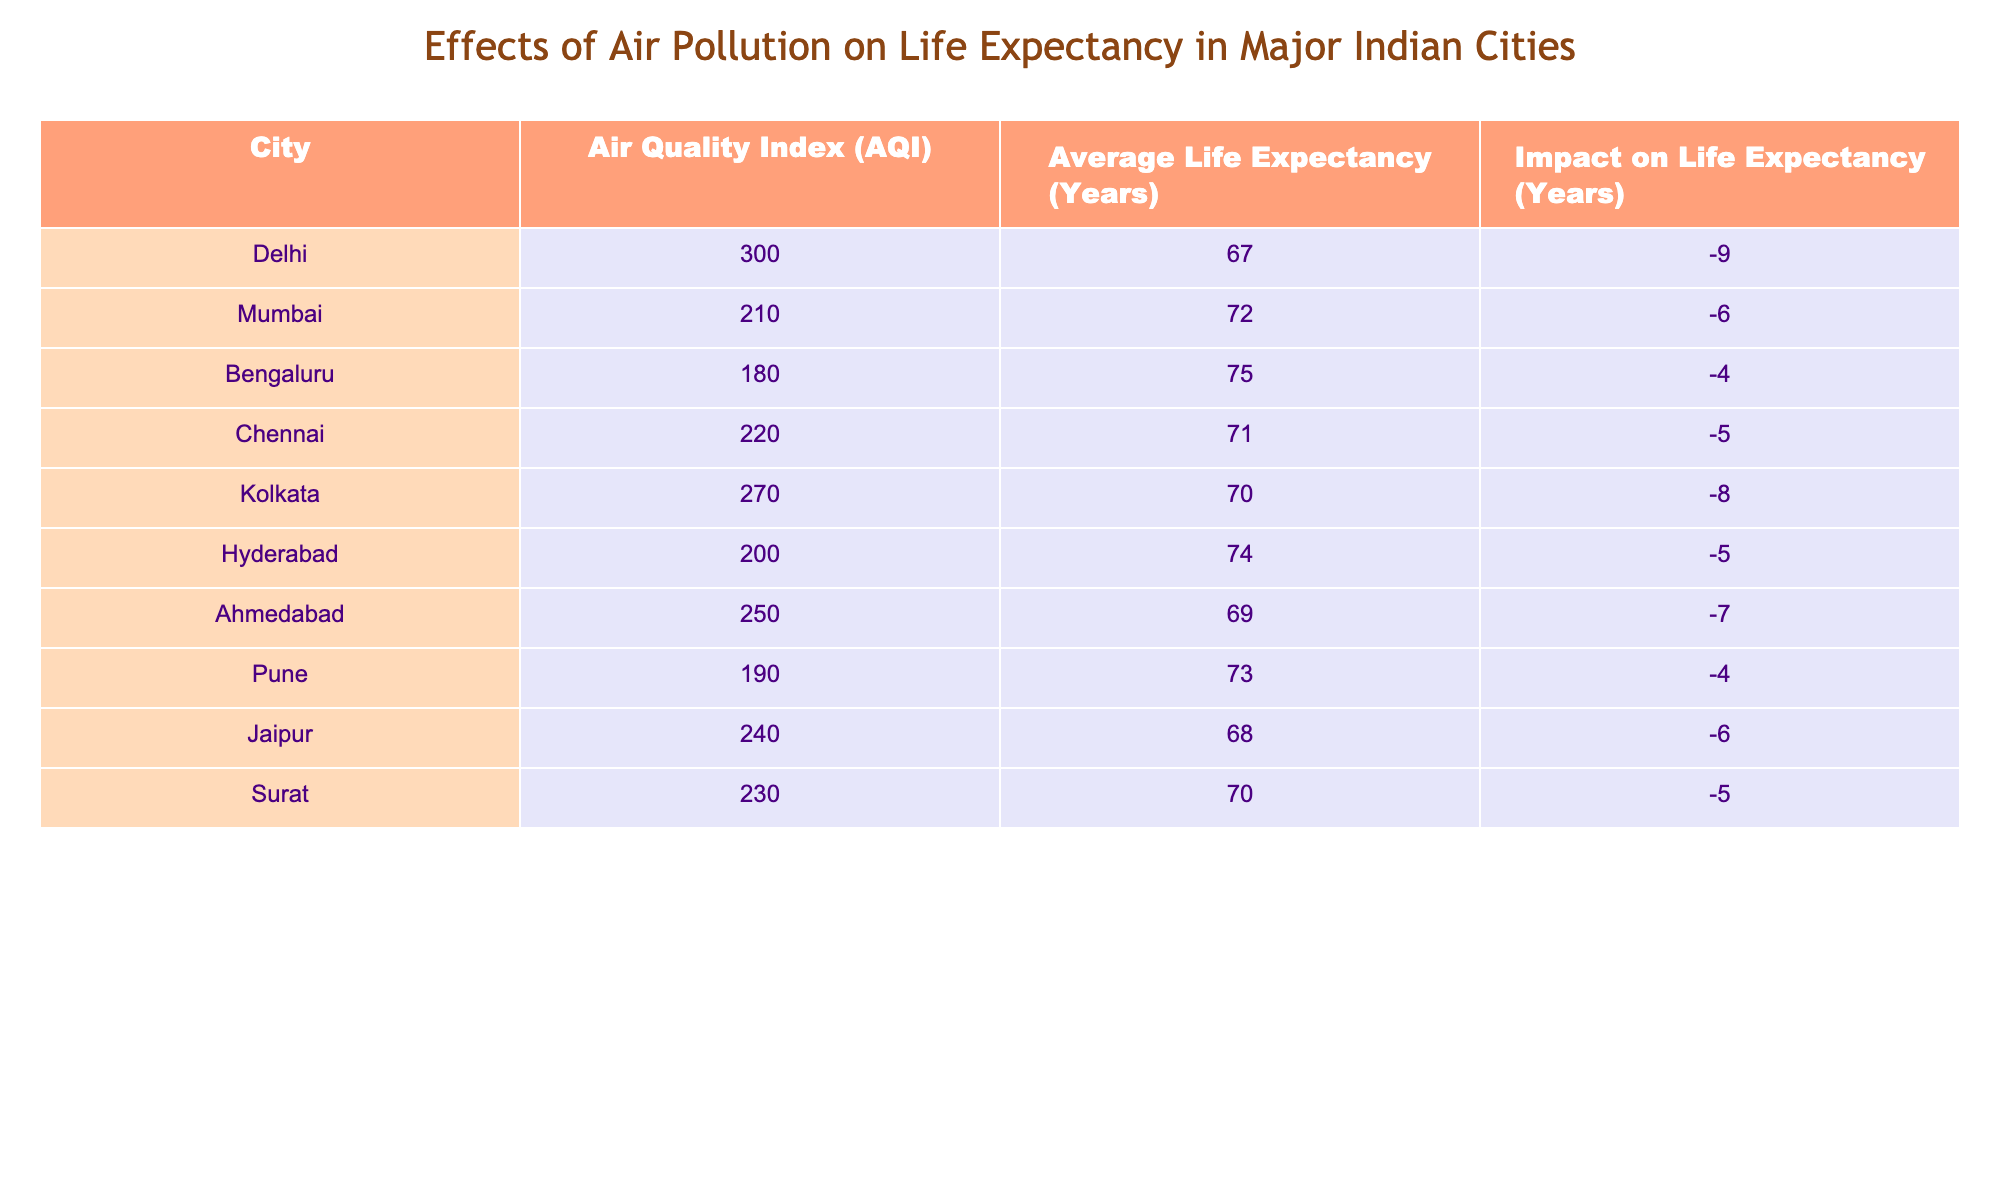What is the air quality index for Mumbai? The table states the air quality index for Mumbai in the specified column, which is directly presented as 210.
Answer: 210 Which city has the lowest average life expectancy? By examining the average life expectancy values in the table, Delhi has the lowest at 67 years.
Answer: 67 What is the impact on life expectancy in Kolkata? The table lists the impact on life expectancy for Kolkata as -8 years, indicating a significant negative effect due to air pollution.
Answer: -8 How does Bengaluru's air quality index compare to that of Chennai? The air quality index for Bengaluru is 180, while for Chennai, it is 220. To compare, Bengaluru’s index is 40 points lower than Chennai’s.
Answer: 40 points lower What is the average life expectancy for Indian cities with an AQI above 250? There are two cities with AQI above 250 (Ahmedabad with 69 and Surat with 70). The average life expectancy is calculated as (69 + 70) / 2 = 69.5.
Answer: 69.5 Is the average life expectancy in Delhi above the national average of 70 years? The average life expectancy in Delhi is 67 years; therefore, it is below the national average of 70 years.
Answer: No Which city has the highest air quality index and what is its impact on life expectancy? The city with the highest air quality index is Delhi with an AQI of 300, and its impact on life expectancy is recorded as -9 years.
Answer: Delhi, -9 If we consider cities with an air quality index lower than 200, what is the total impact on life expectancy? The cities less than an AQI of 200 are Bengaluru, Pune, and Hyderabad. Their impacts are -4, -4, and -5 respectively, totaling -4 + -4 + -5 = -13 years.
Answer: -13 Which city experiences a lesser negative impact on life expectancy, Hyderabad or Ahmedabad? The impact on life expectancy in Hyderabad is -5 years, while in Ahmedabad, it's -7 years. Thus, Hyderabad experiences a lesser negative impact.
Answer: Hyderabad 